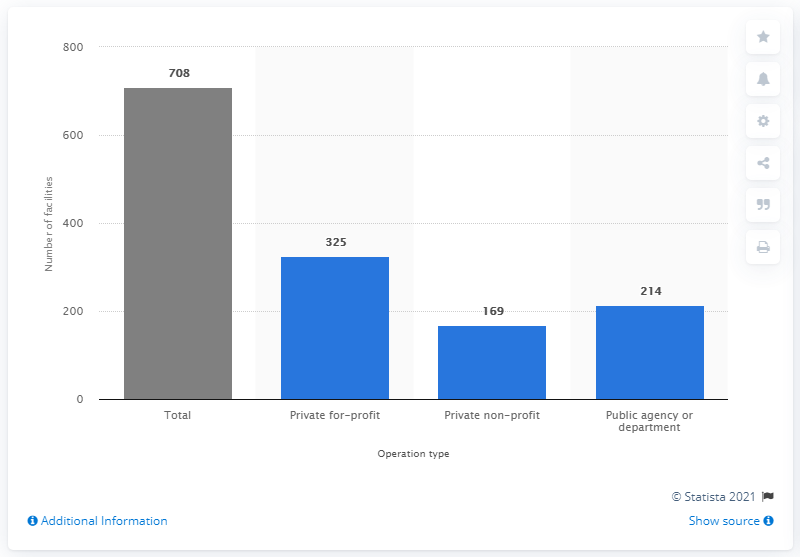List a handful of essential elements in this visual. As of 2019, there were 708 psychiatric hospitals in the United States. 